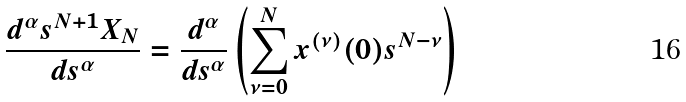Convert formula to latex. <formula><loc_0><loc_0><loc_500><loc_500>\frac { d ^ { \alpha } s ^ { N + 1 } X _ { N } } { d s ^ { \alpha } } = \frac { d ^ { \alpha } } { d s ^ { \alpha } } \left ( \sum _ { \nu = 0 } ^ { N } x ^ { ( \nu ) } ( 0 ) s ^ { N - \nu } \right )</formula> 